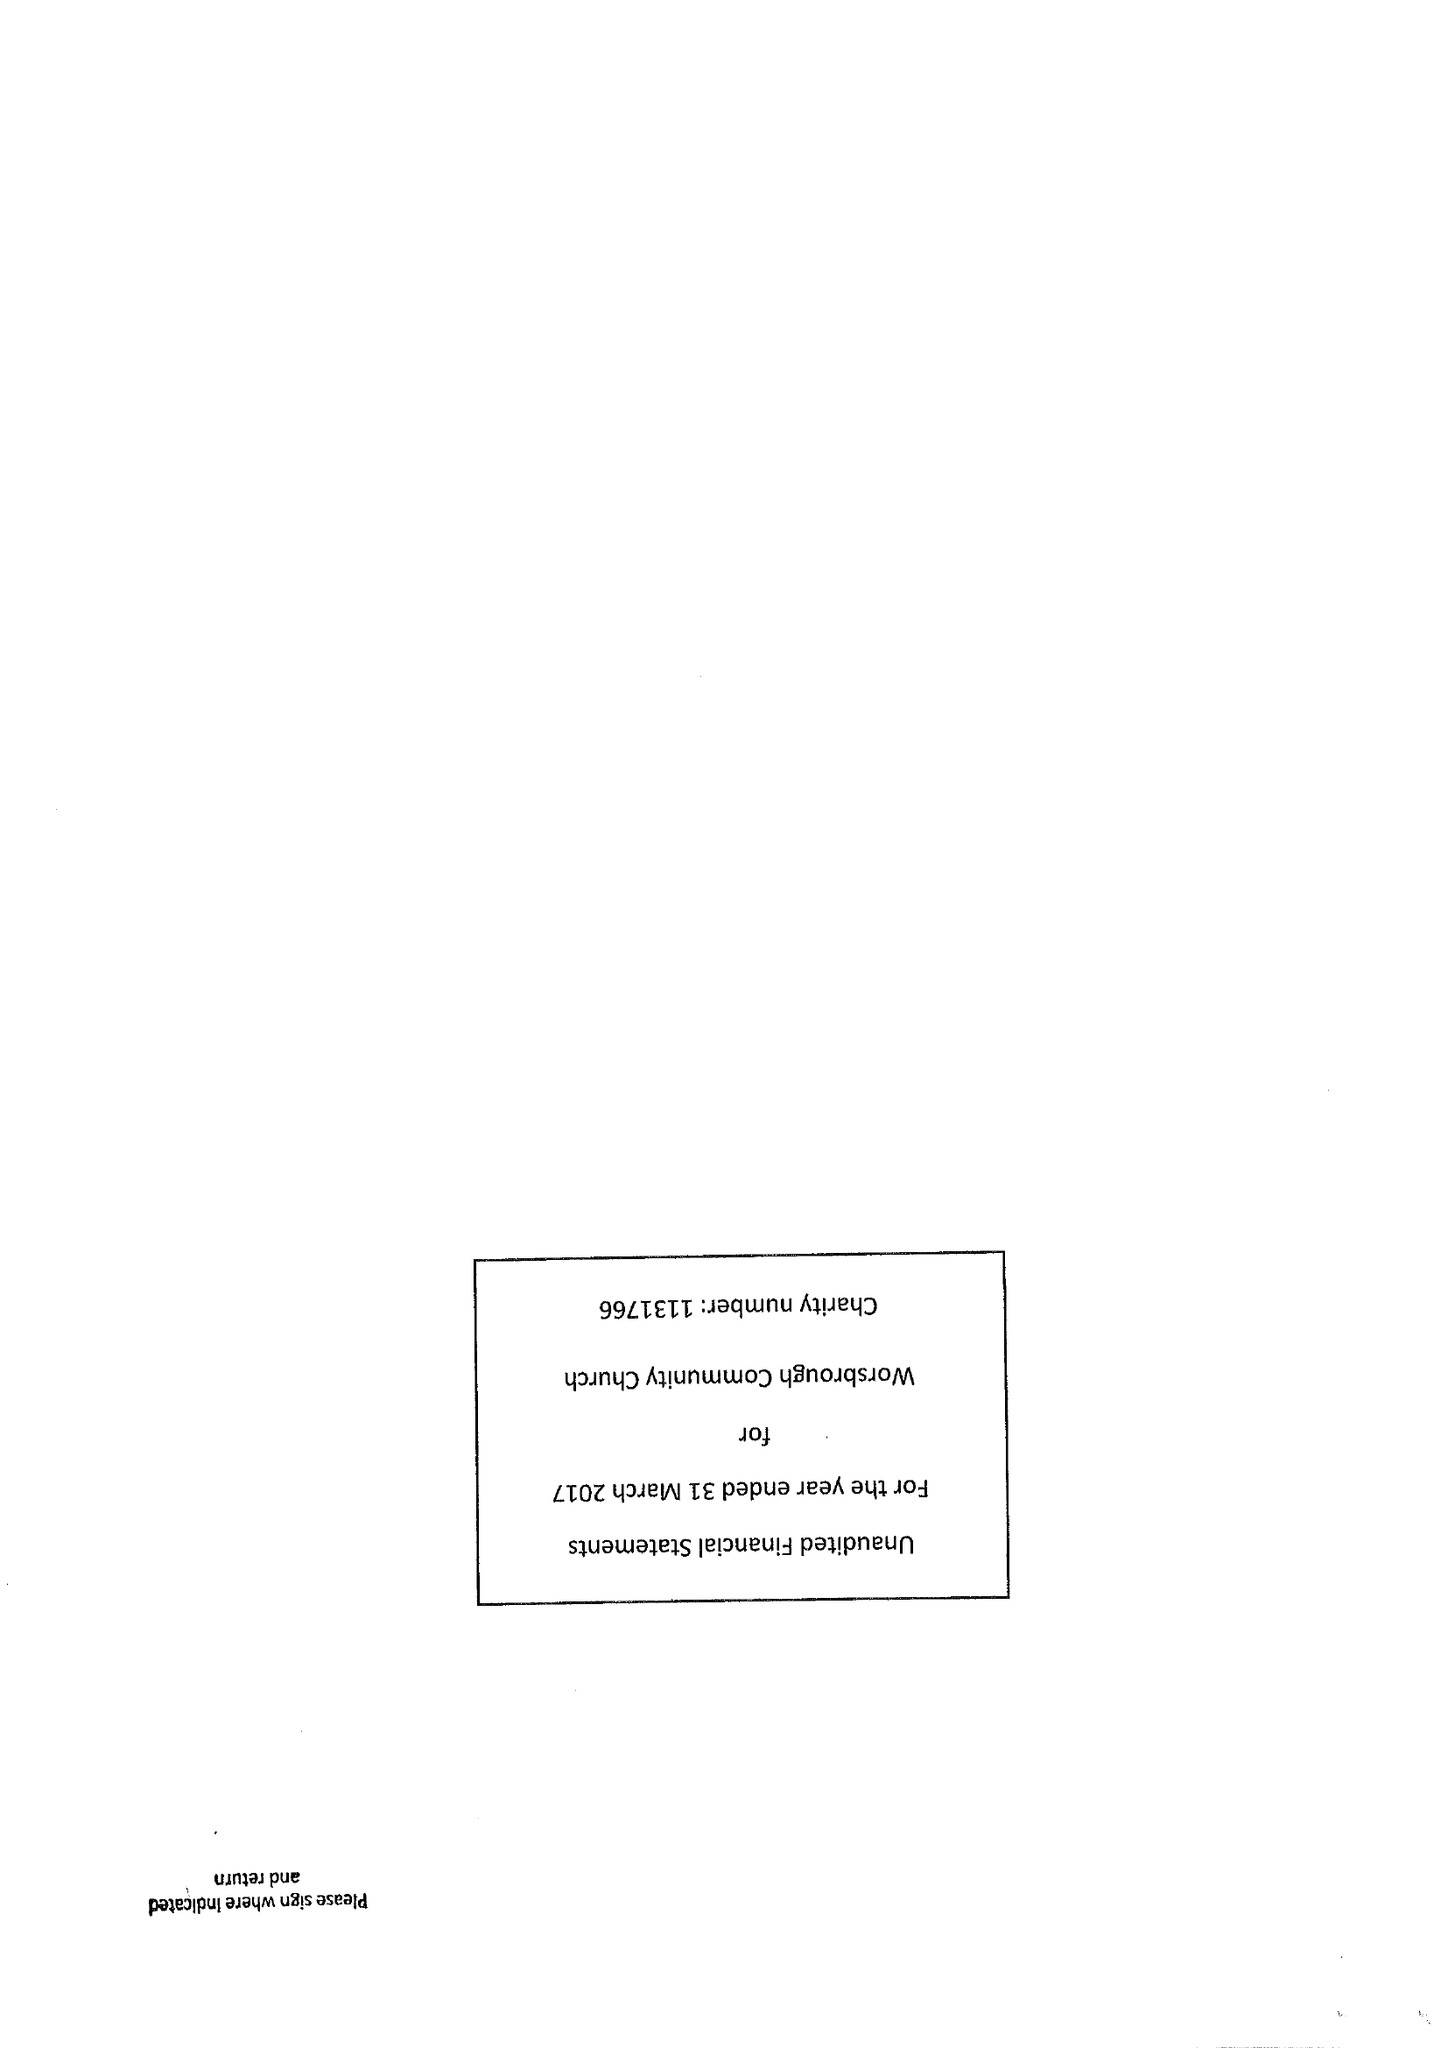What is the value for the address__postcode?
Answer the question using a single word or phrase. S70 4SG 